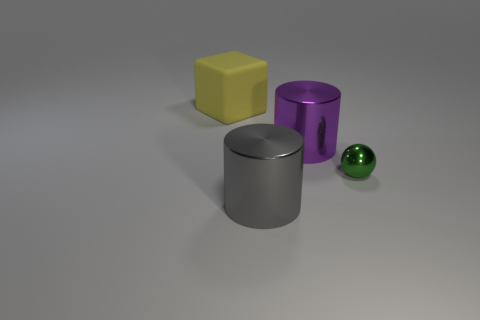There is a big shiny thing that is behind the green metal thing that is behind the shiny thing in front of the tiny metallic object; what is its shape?
Your answer should be compact. Cylinder. How many other things are there of the same shape as the big purple metallic thing?
Your answer should be compact. 1. How many metallic objects are large yellow cubes or blue things?
Ensure brevity in your answer.  0. The large thing behind the big object that is on the right side of the big gray metal object is made of what material?
Keep it short and to the point. Rubber. Are there more big purple cylinders that are left of the large gray object than yellow cubes?
Provide a succinct answer. No. Is there a small brown block made of the same material as the large gray thing?
Ensure brevity in your answer.  No. There is a big metal thing in front of the tiny ball; is it the same shape as the purple metallic thing?
Your response must be concise. Yes. There is a large shiny object that is on the right side of the shiny cylinder that is in front of the tiny thing; how many big shiny things are in front of it?
Your answer should be compact. 1. Are there fewer big cylinders behind the purple cylinder than objects to the right of the yellow matte thing?
Your answer should be very brief. Yes. There is another thing that is the same shape as the gray shiny thing; what is its color?
Your answer should be very brief. Purple. 